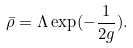Convert formula to latex. <formula><loc_0><loc_0><loc_500><loc_500>\bar { \rho } = \Lambda \exp ( - \frac { 1 } { 2 g } ) .</formula> 